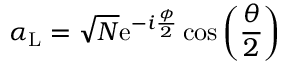Convert formula to latex. <formula><loc_0><loc_0><loc_500><loc_500>\alpha _ { L } = \sqrt { N } e ^ { - i \frac { \phi } { 2 } } \cos \left ( \frac { \theta } { 2 } \right )</formula> 